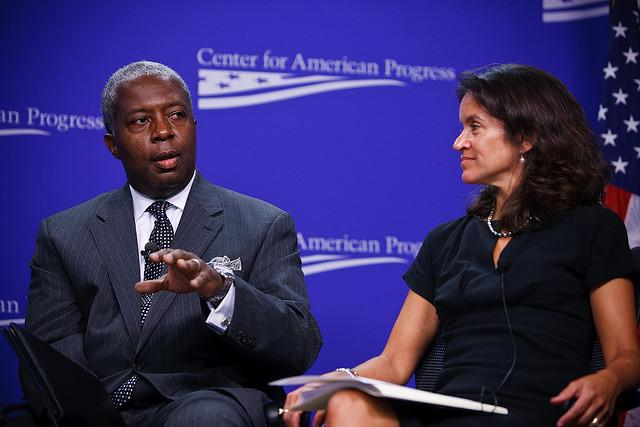What type talk is being given here?

Choices:
A) panel
B) debate
C) argument
D) barnburner panel 